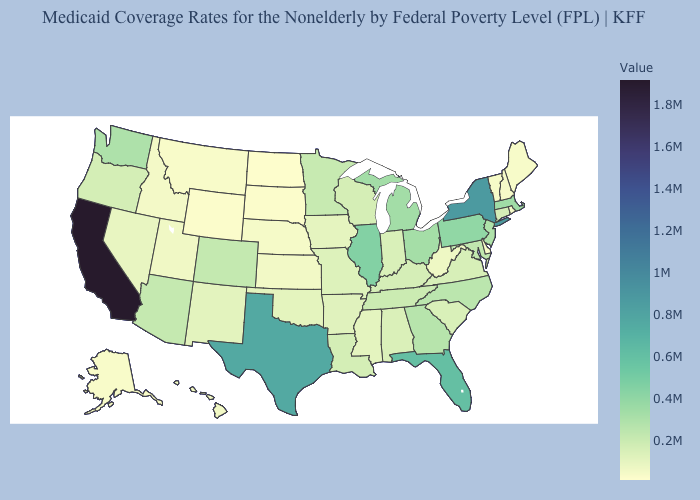Among the states that border Wyoming , does South Dakota have the lowest value?
Quick response, please. Yes. Does California have the highest value in the USA?
Give a very brief answer. Yes. Does Florida have the lowest value in the USA?
Keep it brief. No. Which states hav the highest value in the South?
Keep it brief. Texas. Among the states that border Georgia , does Alabama have the lowest value?
Short answer required. Yes. Does the map have missing data?
Keep it brief. No. 